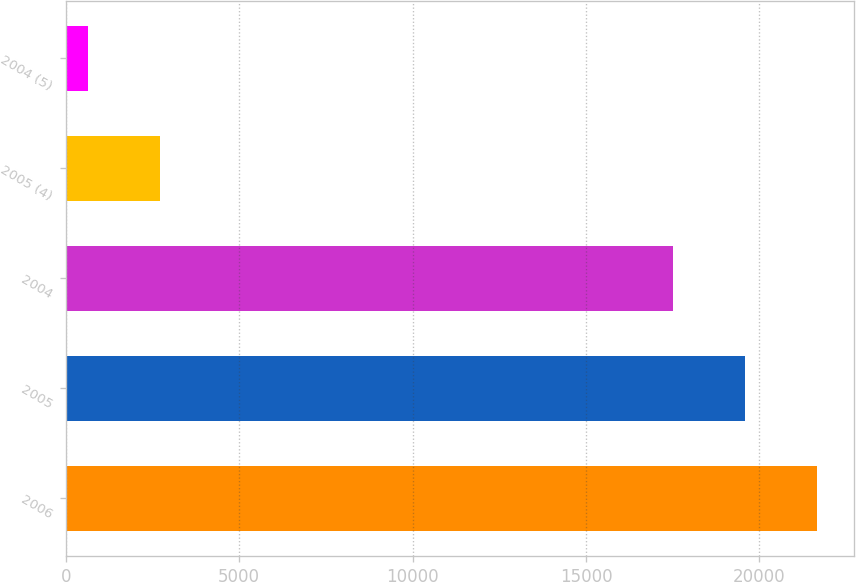Convert chart to OTSL. <chart><loc_0><loc_0><loc_500><loc_500><bar_chart><fcel>2006<fcel>2005<fcel>2004<fcel>2005 (4)<fcel>2004 (5)<nl><fcel>21660.4<fcel>19578.7<fcel>17497<fcel>2710.7<fcel>629<nl></chart> 